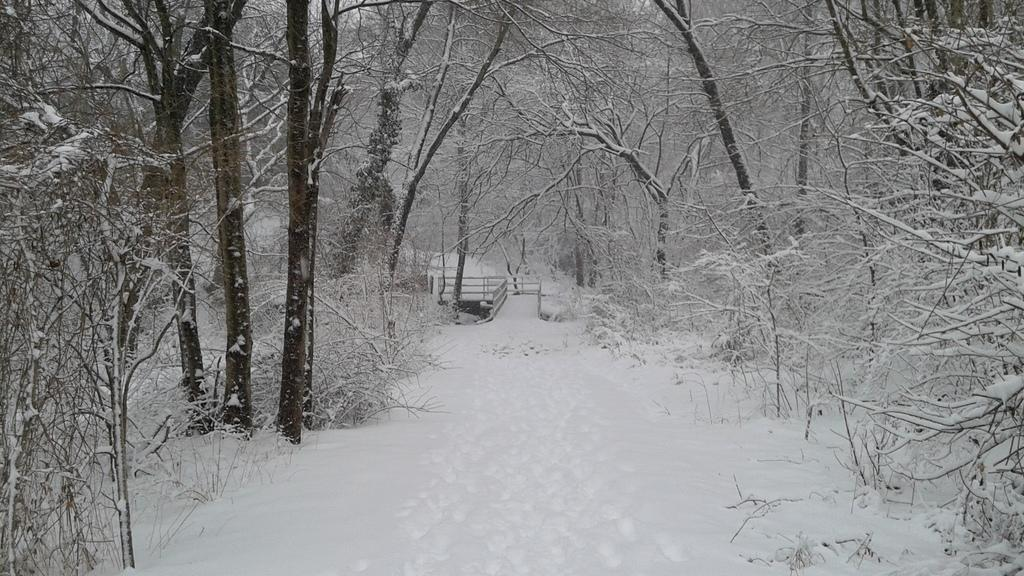What type of vegetation can be seen in the image? There are trees in the image. What is the weather like in the image? There is snow in the image, indicating a cold or wintery environment. What type of structure is present in the image? There is a bridge in the image. How many ants can be seen carrying the lead in the image? There are no ants or lead present in the image. What part of the brain is visible in the image? There is no brain present in the image. 